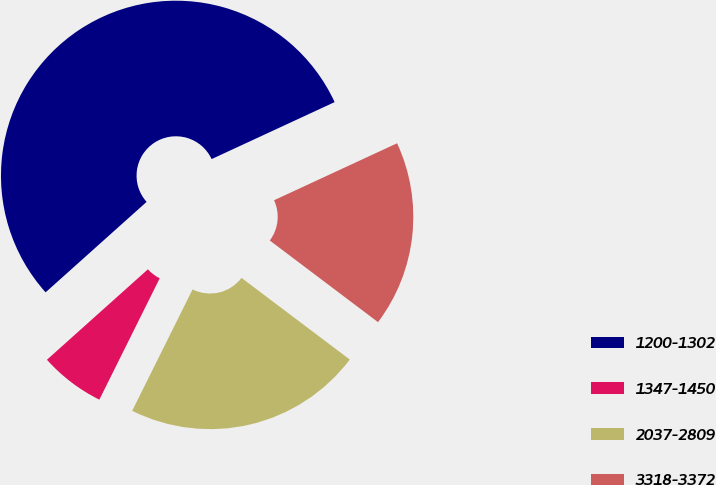Convert chart to OTSL. <chart><loc_0><loc_0><loc_500><loc_500><pie_chart><fcel>1200-1302<fcel>1347-1450<fcel>2037-2809<fcel>3318-3372<nl><fcel>54.72%<fcel>6.03%<fcel>22.06%<fcel>17.19%<nl></chart> 